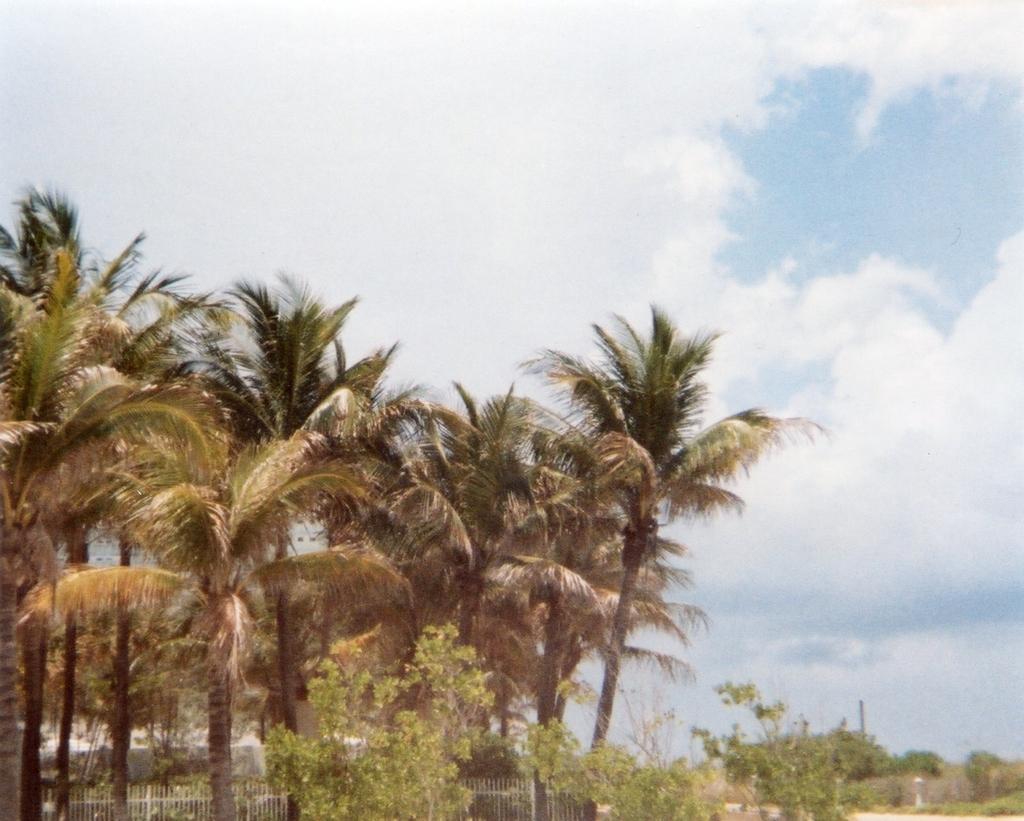Describe this image in one or two sentences. In this image there are coconut trees on the left side. At the bottom there is a fence. At the top there is the sky. There is land at the bottom. On the land there are plants. 